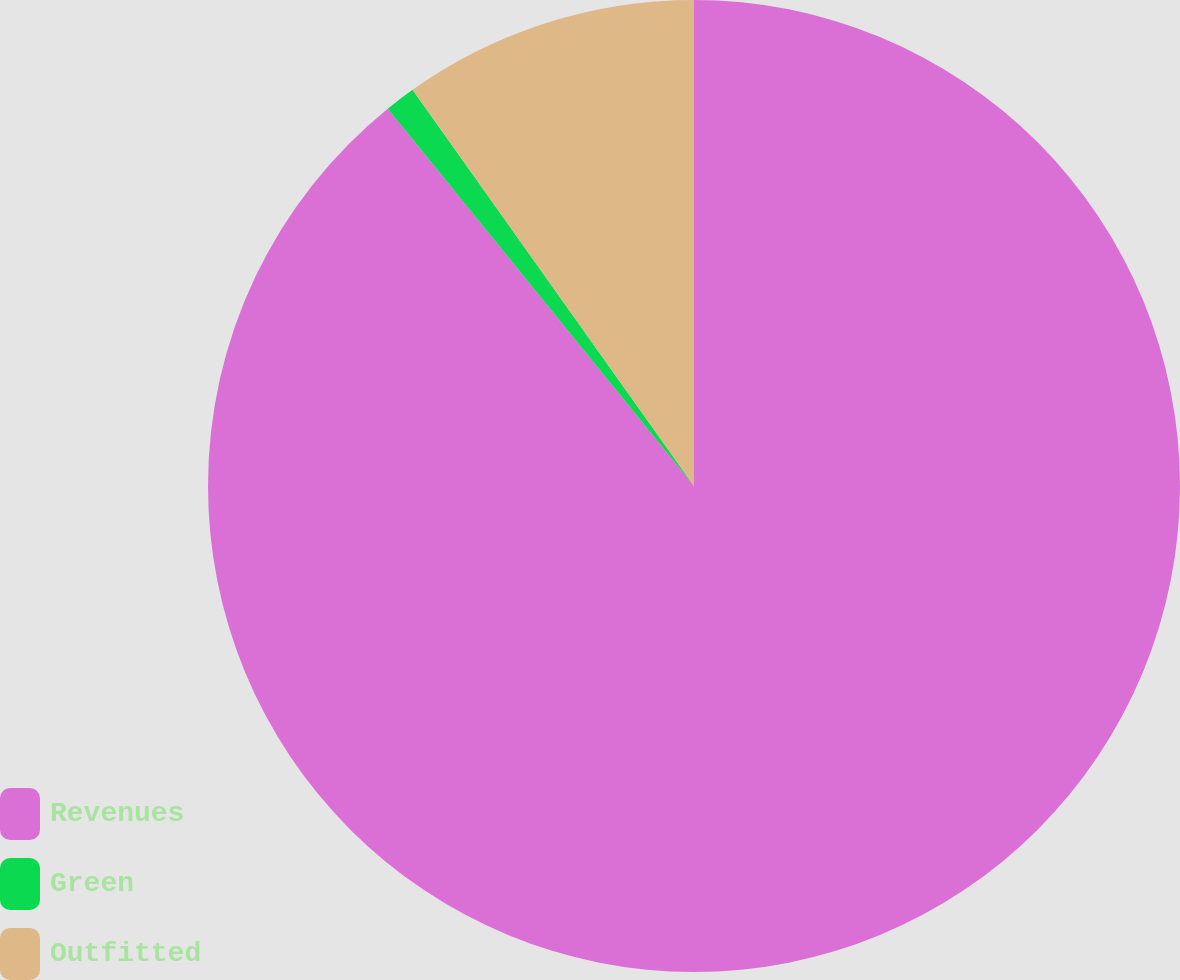Convert chart. <chart><loc_0><loc_0><loc_500><loc_500><pie_chart><fcel>Revenues<fcel>Green<fcel>Outfitted<nl><fcel>89.15%<fcel>1.02%<fcel>9.83%<nl></chart> 